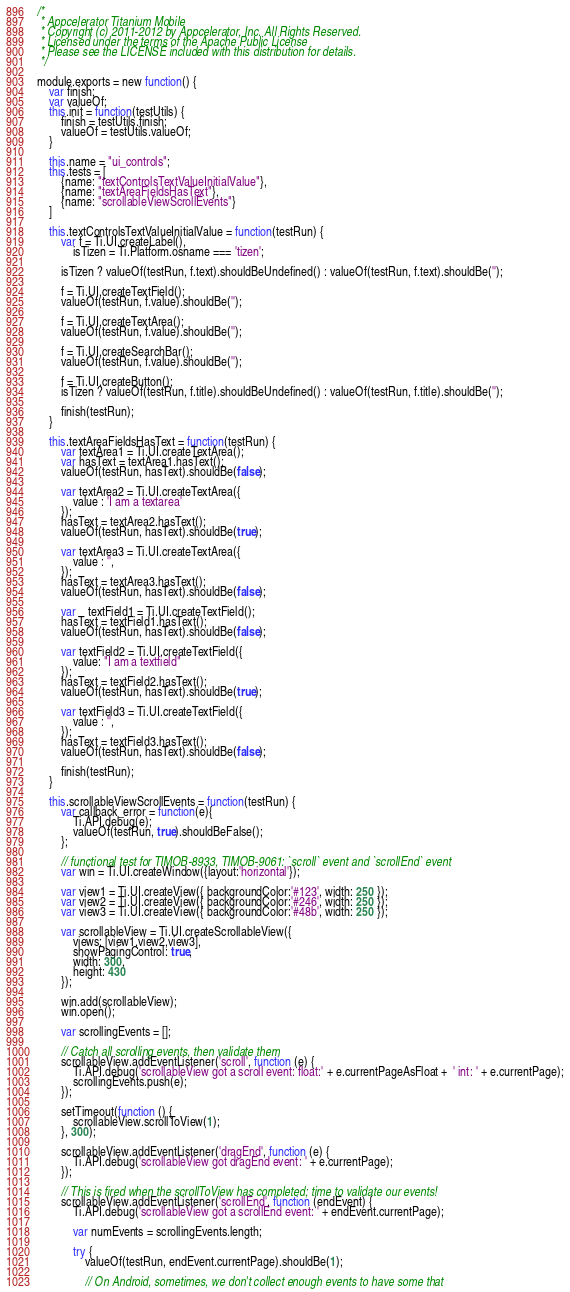Convert code to text. <code><loc_0><loc_0><loc_500><loc_500><_JavaScript_>/*
 * Appcelerator Titanium Mobile
 * Copyright (c) 2011-2012 by Appcelerator, Inc. All Rights Reserved.
 * Licensed under the terms of the Apache Public License
 * Please see the LICENSE included with this distribution for details.
 */
 
module.exports = new function() {
	var finish;
	var valueOf;
	this.init = function(testUtils) {
		finish = testUtils.finish;
		valueOf = testUtils.valueOf;
	}

	this.name = "ui_controls";
	this.tests = [
		{name: "textControlsTextValueInitialValue"},
		{name: "textAreaFieldsHasText"},
		{name: "scrollableViewScrollEvents"}
	]

	this.textControlsTextValueInitialValue = function(testRun) {
		var f = Ti.UI.createLabel(),
			isTizen = Ti.Platform.osname === 'tizen';

		isTizen ? valueOf(testRun, f.text).shouldBeUndefined() : valueOf(testRun, f.text).shouldBe('');

		f = Ti.UI.createTextField();
		valueOf(testRun, f.value).shouldBe('');

		f = Ti.UI.createTextArea();
		valueOf(testRun, f.value).shouldBe('');
		
		f = Ti.UI.createSearchBar();
		valueOf(testRun, f.value).shouldBe('');
		
		f = Ti.UI.createButton();
		isTizen ? valueOf(testRun, f.title).shouldBeUndefined() : valueOf(testRun, f.title).shouldBe('');

		finish(testRun);
	}

	this.textAreaFieldsHasText = function(testRun) {
		var textArea1 = Ti.UI.createTextArea();
		var hasText = textArea1.hasText();
		valueOf(testRun, hasText).shouldBe(false);
		
		var textArea2 = Ti.UI.createTextArea({
			value : 'I am a textarea'   
		});
		hasText = textArea2.hasText();
		valueOf(testRun, hasText).shouldBe(true);
		
		var textArea3 = Ti.UI.createTextArea({
			value : '',
		});
		hasText = textArea3.hasText();
		valueOf(testRun, hasText).shouldBe(false);
		
		var	textField1 = Ti.UI.createTextField();
		hasText = textField1.hasText();
		valueOf(testRun, hasText).shouldBe(false);
		
		var textField2 = Ti.UI.createTextField({
			value: "I am a textfield"
		});
		hasText = textField2.hasText();
		valueOf(testRun, hasText).shouldBe(true);
		
		var textField3 = Ti.UI.createTextField({
			value : '',
		});
		hasText = textField3.hasText();
		valueOf(testRun, hasText).shouldBe(false);

		finish(testRun);
	}

	this.scrollableViewScrollEvents = function(testRun) {
		var callback_error = function(e){
			Ti.API.debug(e);
			valueOf(testRun, true).shouldBeFalse();
		};
		
		// functional test for TIMOB-8933, TIMOB-9061: `scroll` event and `scrollEnd` event
    	var win = Ti.UI.createWindow({layout:'horizontal'});

    	var view1 = Ti.UI.createView({ backgroundColor:'#123', width: 250 });
    	var view2 = Ti.UI.createView({ backgroundColor:'#246', width: 250 });
    	var view3 = Ti.UI.createView({ backgroundColor:'#48b', width: 250 });

    	var scrollableView = Ti.UI.createScrollableView({
      		views: [view1,view2,view3],
      		showPagingControl: true,
      		width: 300,
      		height: 430
    	});

    	win.add(scrollableView);
    	win.open();

    	var scrollingEvents = [];

    	// Catch all scrolling events, then validate them
    	scrollableView.addEventListener('scroll', function (e) {
      		Ti.API.debug('scrollableView got a scroll event: float:' + e.currentPageAsFloat +  ' int: ' + e.currentPage);
      		scrollingEvents.push(e);
    	});

    	setTimeout(function () {
      		scrollableView.scrollToView(1);
    	}, 300);

    	scrollableView.addEventListener('dragEnd', function (e) {
      		Ti.API.debug('scrollableView got dragEnd event: ' + e.currentPage);
    	});

    	// This is fired when the scrollToView has completed; time to validate our events!
    	scrollableView.addEventListener('scrollEnd', function (endEvent) {
      		Ti.API.debug('scrollableView got a scrollEnd event: ' + endEvent.currentPage);

      		var numEvents = scrollingEvents.length;

      		try {
        		valueOf(testRun, endEvent.currentPage).shouldBe(1);

        		// On Android, sometimes, we don't collect enough events to have some that </code> 